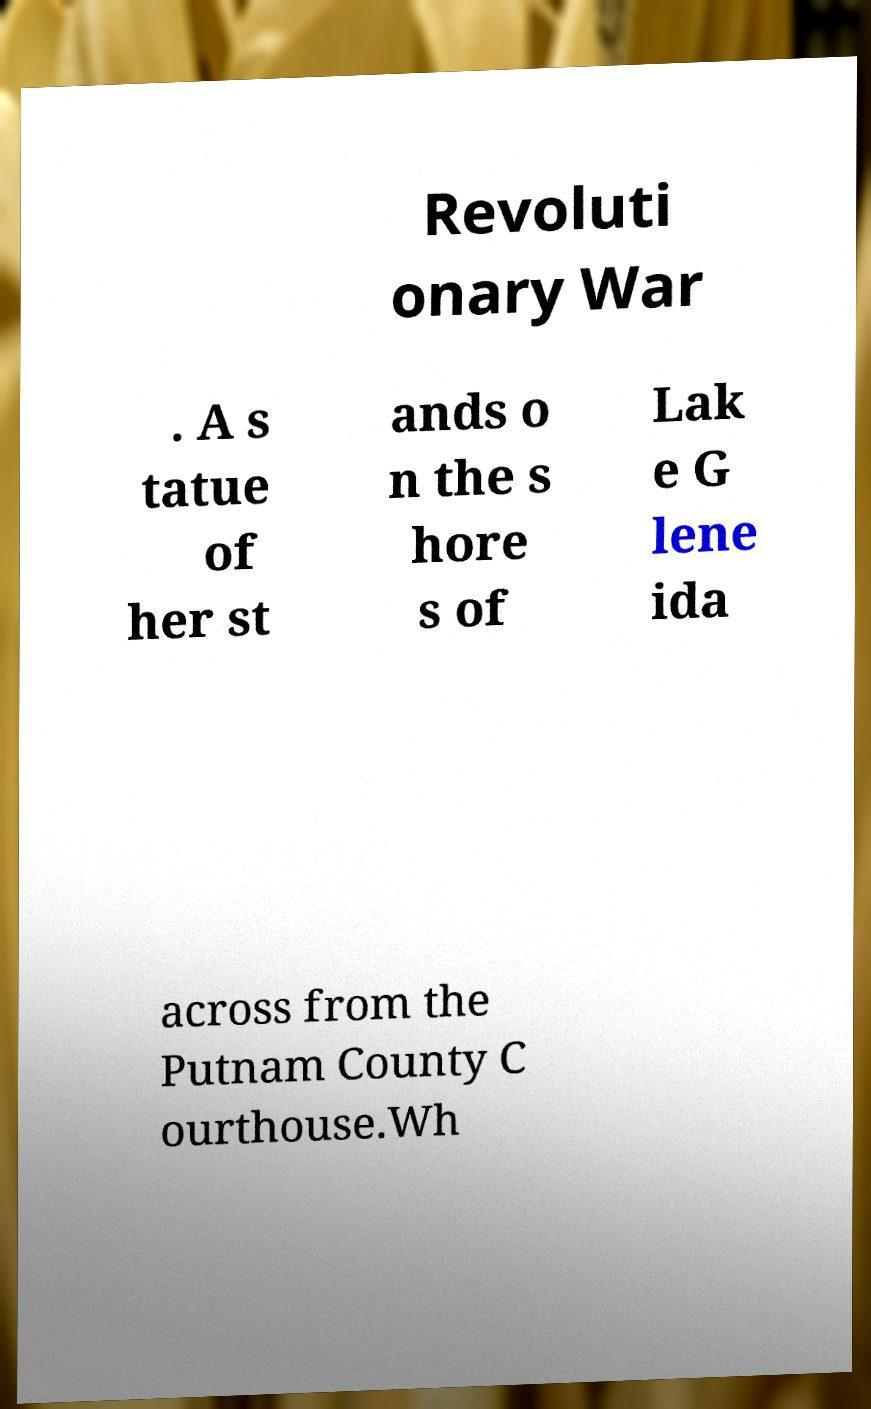There's text embedded in this image that I need extracted. Can you transcribe it verbatim? Revoluti onary War . A s tatue of her st ands o n the s hore s of Lak e G lene ida across from the Putnam County C ourthouse.Wh 